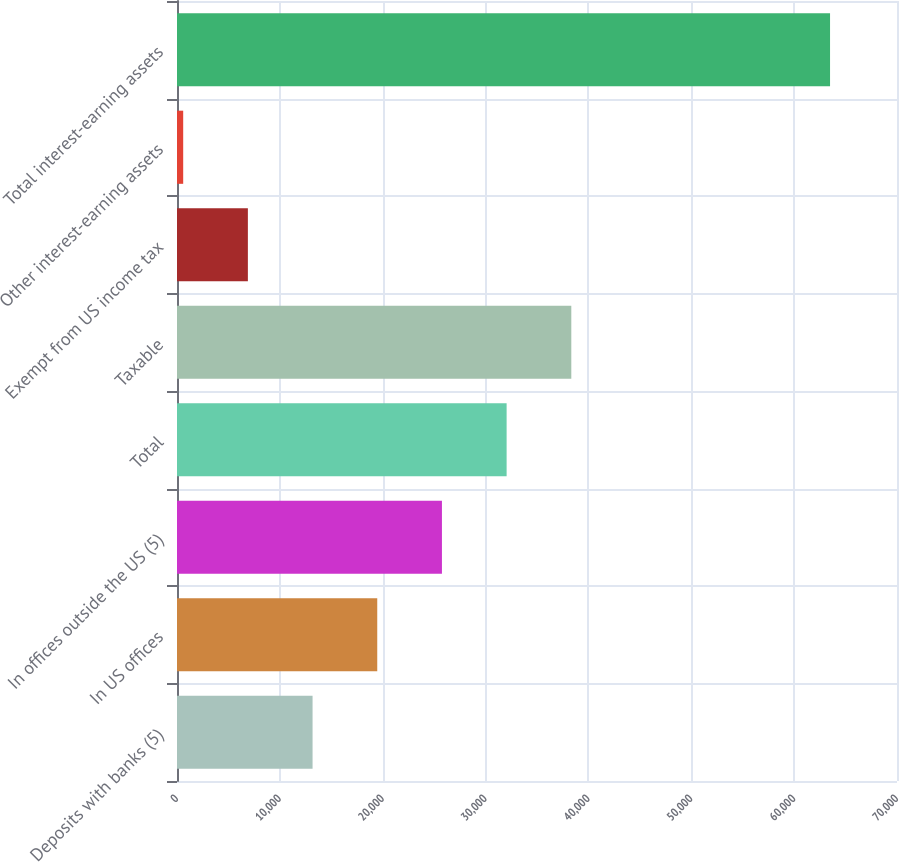<chart> <loc_0><loc_0><loc_500><loc_500><bar_chart><fcel>Deposits with banks (5)<fcel>In US offices<fcel>In offices outside the US (5)<fcel>Total<fcel>Taxable<fcel>Exempt from US income tax<fcel>Other interest-earning assets<fcel>Total interest-earning assets<nl><fcel>13179.8<fcel>19468.7<fcel>25757.6<fcel>32046.5<fcel>38335.4<fcel>6890.9<fcel>602<fcel>63491<nl></chart> 